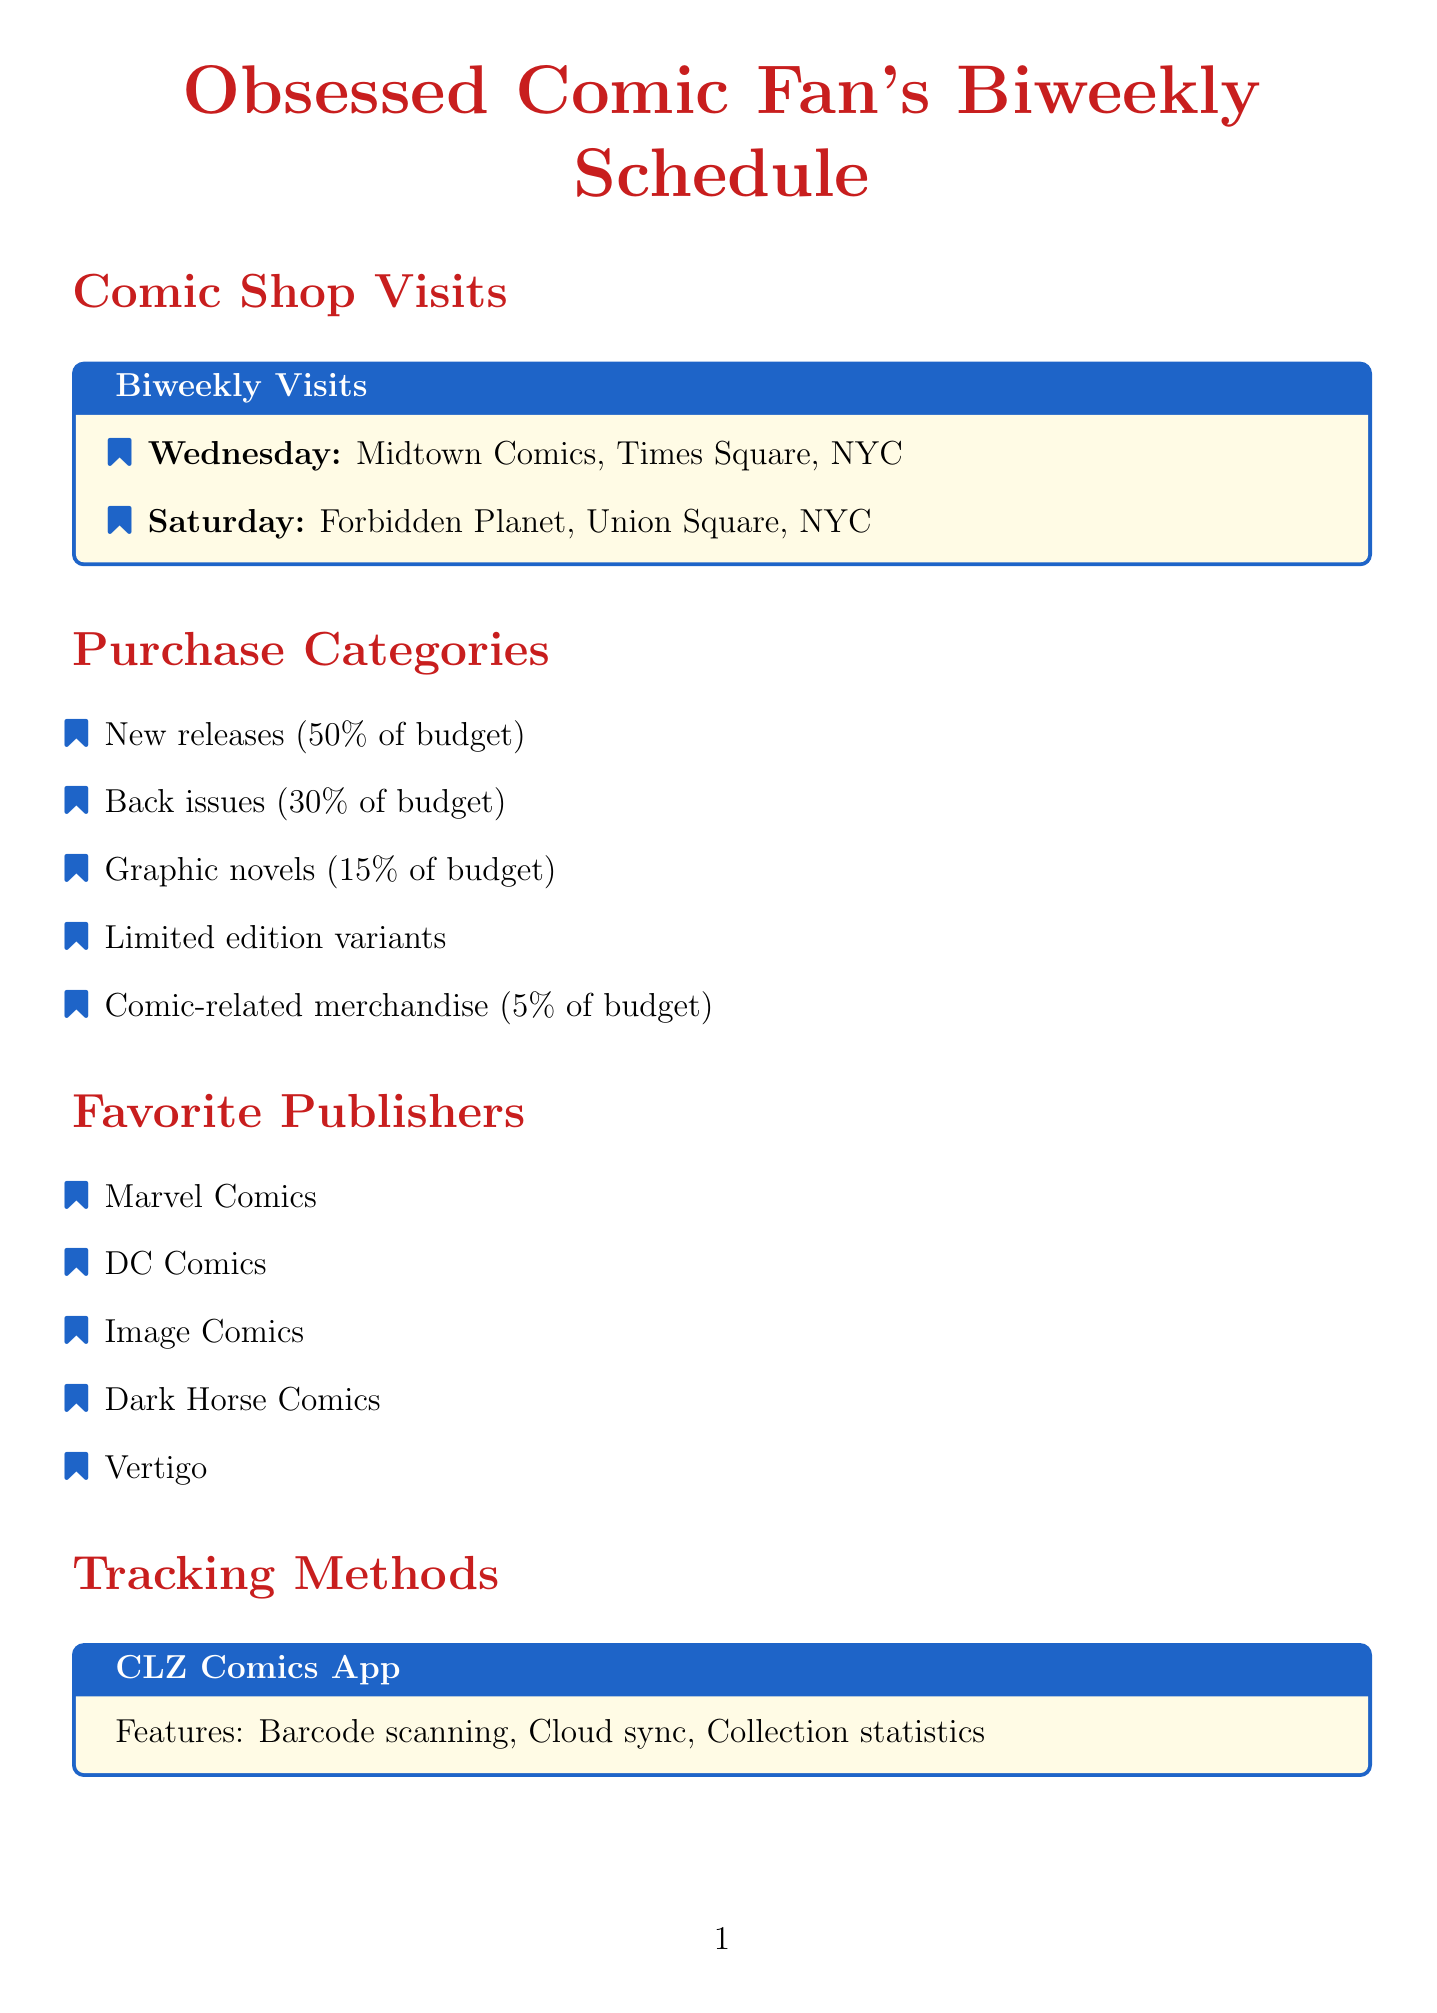What is the first comic shop visit day? The document lists the first visit day as Wednesday, when visiting Midtown Comics.
Answer: Wednesday What is the budget percentage for new releases? According to the budget allocation section, new releases account for 50 percent of the budget.
Answer: 50% Which comic series is on the pull list? The pull list includes various series, one of which is Batman.
Answer: Batman What is the name of the value tracking tool? The document specifies that the tool used for value tracking is GoCollect.
Answer: GoCollect What is the frequency of comic shop visits? The document states that the visits occur biweekly.
Answer: Biweekly What is included in the avoid list? The avoid list includes any comics featuring Tyrese Gibson.
Answer: Any comics featuring Tyrese Gibson What is the storage method mentioned for organization? The document mentions long boxes as one of the storage methods for organization.
Answer: Long boxes What is the special event that occurs on the first Saturday in May? The document states that Free Comic Book Day occurs on the first Saturday in May.
Answer: Free Comic Book Day What percentage of the budget is allocated to comic-related merchandise? The budget allocation for comic-related merchandise is listed as 5 percent.
Answer: 5% 